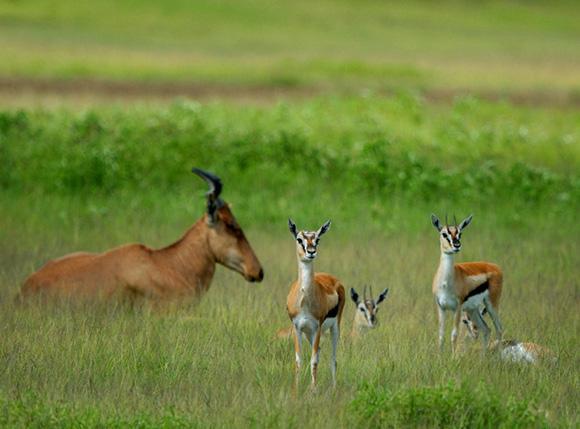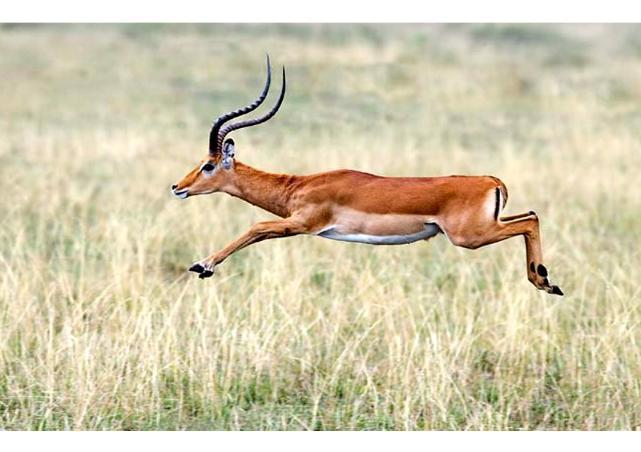The first image is the image on the left, the second image is the image on the right. Considering the images on both sides, is "The animal in the image on the right is standing in side profile with its head turned toward the camera." valid? Answer yes or no. No. 